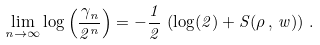Convert formula to latex. <formula><loc_0><loc_0><loc_500><loc_500>\lim _ { n \to \infty } \log \left ( \frac { \gamma _ { n } } { 2 ^ { n } } \right ) = - \frac { 1 } { 2 } \, \left ( \log ( 2 ) + S ( \rho \, , \, w ) \right ) \, .</formula> 